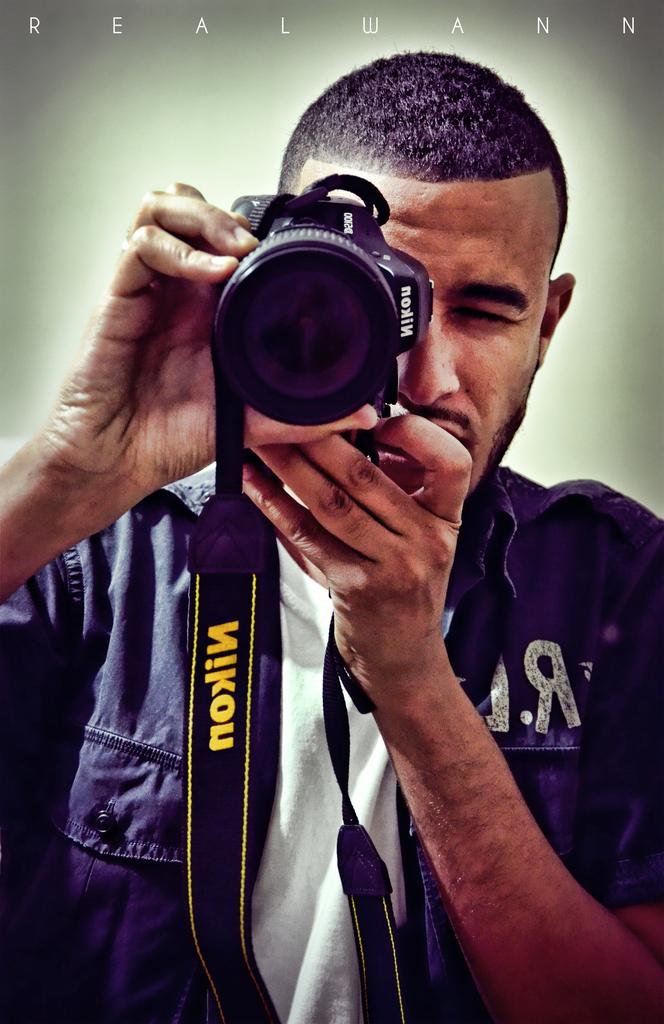What is the main subject of the image? The main subject of the image is a man. What is the man holding in his hand? The man is holding a camera in his hand. How many rabbits can be seen in the image? There are no rabbits present in the image. What type of house is visible in the background of the image? There is no house visible in the image; it only features a man holding a camera. 